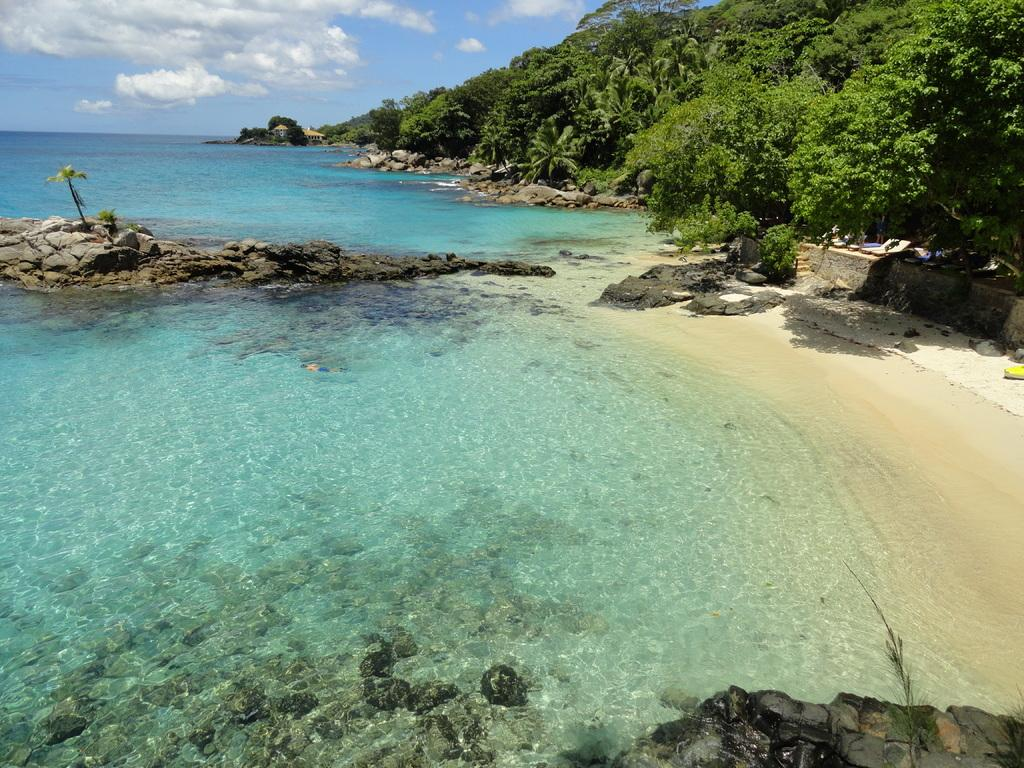What is one of the main elements in the image? There is water in the image. What other natural elements can be seen in the image? There are trees and rocks in the image. What is visible in the background of the image? The sky is visible in the image. What can be observed in the sky? Clouds are present in the sky. What type of curtain can be seen hanging from the trees in the image? There is no curtain present in the image; it features water, trees, rocks, and clouds. How many yams are visible in the image? There are no yams present in the image. 